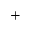<formula> <loc_0><loc_0><loc_500><loc_500>^ { + }</formula> 